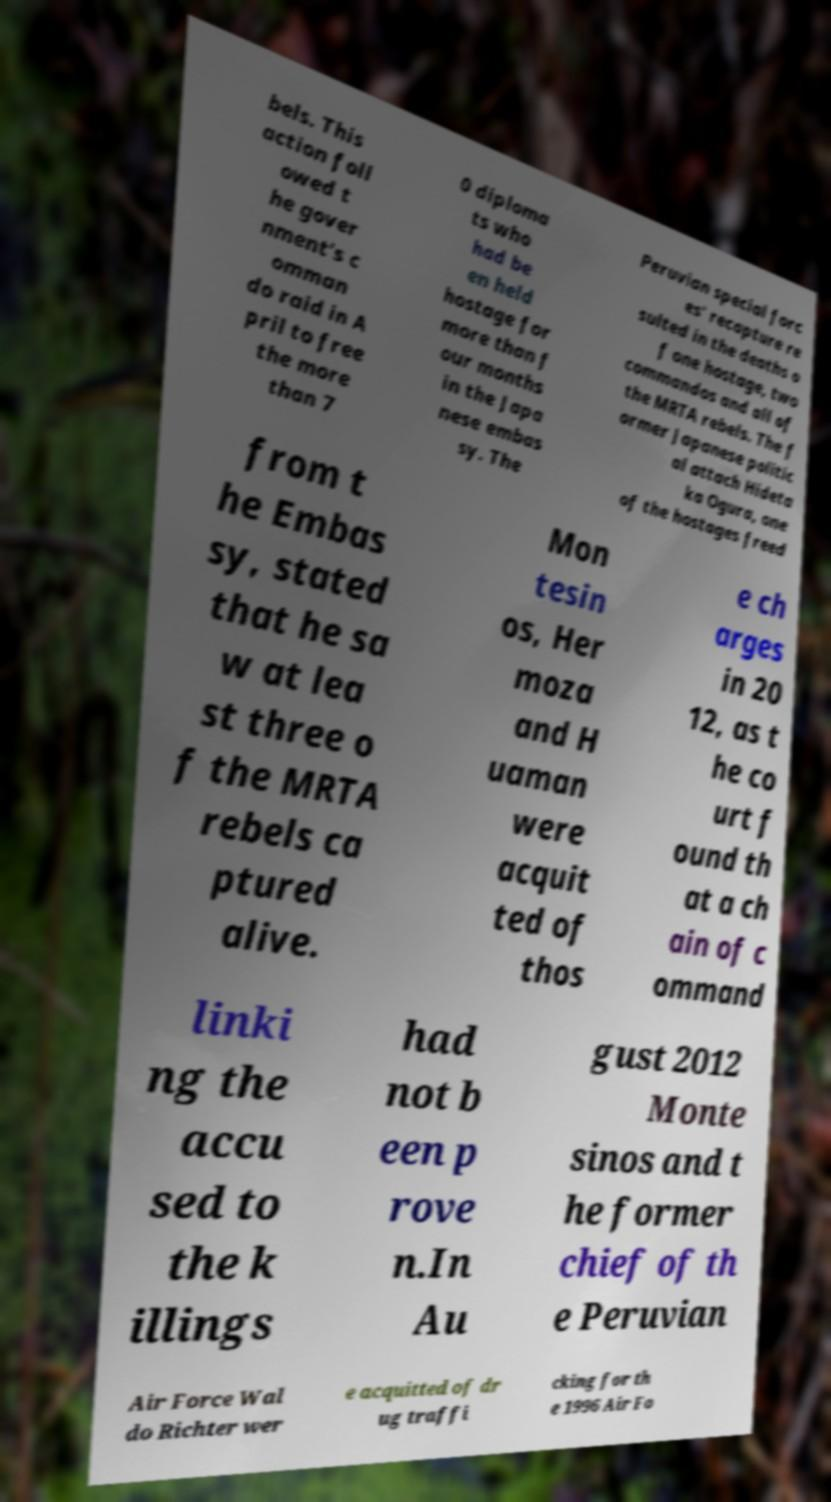Please identify and transcribe the text found in this image. bels. This action foll owed t he gover nment's c omman do raid in A pril to free the more than 7 0 diploma ts who had be en held hostage for more than f our months in the Japa nese embas sy. The Peruvian special forc es' recapture re sulted in the deaths o f one hostage, two commandos and all of the MRTA rebels. The f ormer Japanese politic al attach Hideta ka Ogura, one of the hostages freed from t he Embas sy, stated that he sa w at lea st three o f the MRTA rebels ca ptured alive. Mon tesin os, Her moza and H uaman were acquit ted of thos e ch arges in 20 12, as t he co urt f ound th at a ch ain of c ommand linki ng the accu sed to the k illings had not b een p rove n.In Au gust 2012 Monte sinos and t he former chief of th e Peruvian Air Force Wal do Richter wer e acquitted of dr ug traffi cking for th e 1996 Air Fo 